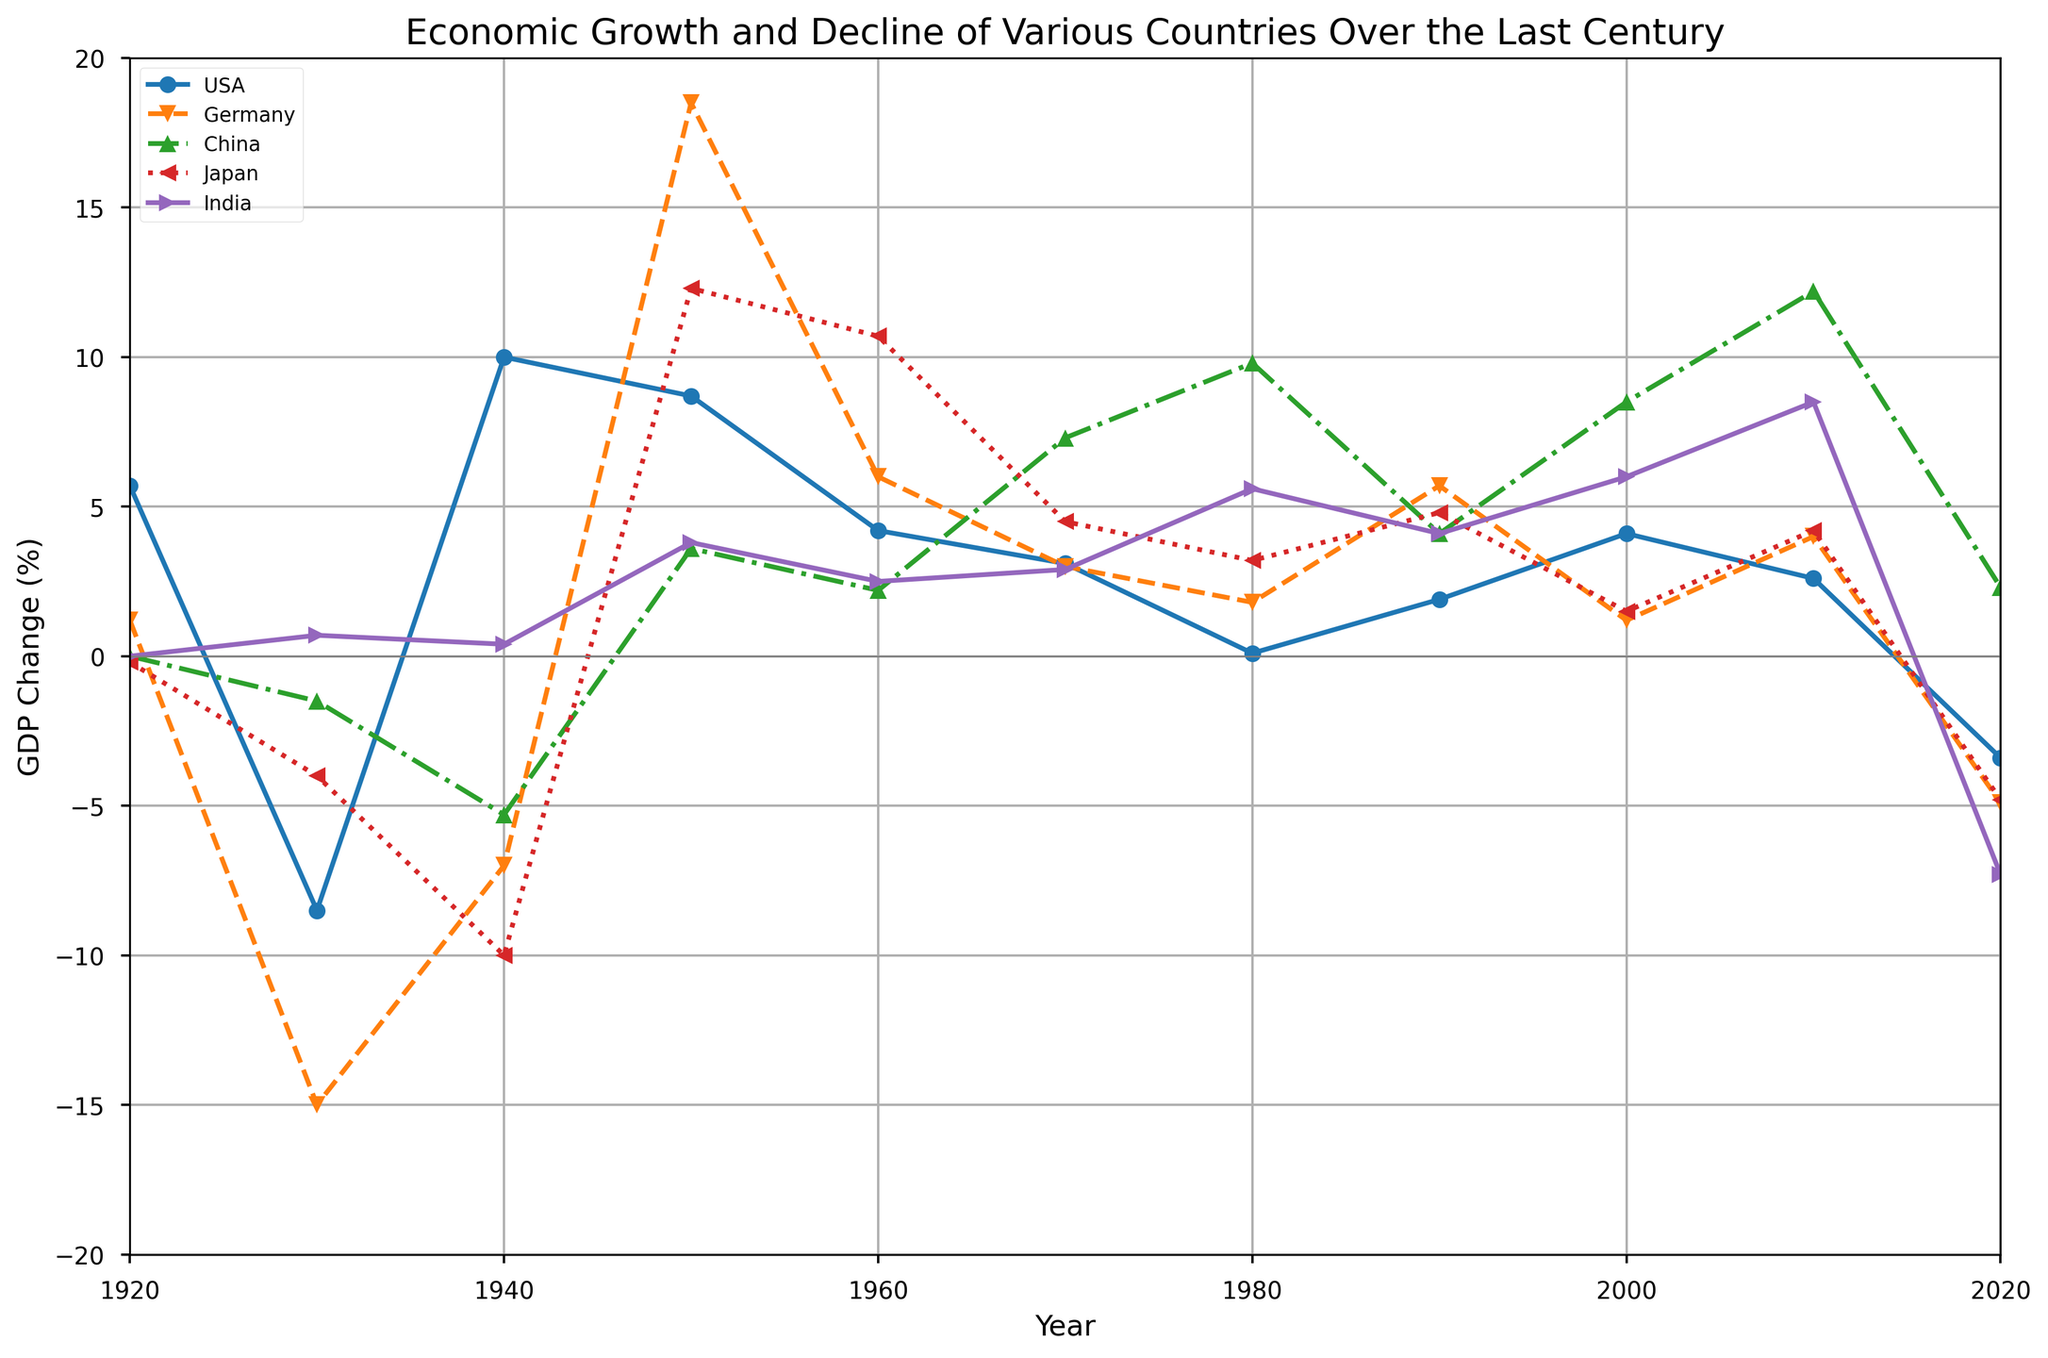How did the economic growth of the USA change from 1930 to 1940? The chart shows negative GDP change in the USA in 1930 and positive GDP change in 1940. Thus, there was an increase. Specifically, from -8.5% in 1930 to 10.0% in 1940.
Answer: Economic growth significantly increased Which country had the highest GDP change in 1950? By observing the peaks on the chart for 1950, Germany had the highest GDP change. The GDP change for Germany in 1950 is 18.5%, which is the highest among all countries that year.
Answer: Germany How does the GDP change in 2020 for India compare with Japan? The GDP change for India in 2020 is -7.3% while for Japan it is -4.8%. Comparing these values, India's GDP decline is greater than Japan's.
Answer: India's GDP decline is greater Which two countries experienced a negative GDP growth during the 1930s? Observing the drop below zero on the chart for the 1930s, the USA and Germany had negative GDP growth. USA has -8.5% and Germany has -15.0% in the 1930s.
Answer: USA and Germany What's the average GDP change of China in the last four observed periods (1990, 2000, 2010, 2020)? The GDP changes for China in those periods are 4.1, 8.5, 12.2, and 2.3. Summing them gives 27.1. Dividing by 4 gives the average value of approximately 6.775%.
Answer: 6.775% Which country had higher economic growth during the 1960s, Japan or India? Observing the points for each country in the 1960s on the chart, Japan had a GDP change of 10.7% whereas India had 2.5%. Thus, Japan had higher growth.
Answer: Japan Did any country show consistent year-over-year GDP increases from 1920 to 2020? Observing the chart, no country shows a consistent year-over-year increase throughout the whole period. Each country has periods of both positive and negative GDP changes.
Answer: No In which decade did Germany experience the largest growth rate increase? By identifying the largest upward spike on Germany's line, the 1950s show the largest increase from previous years, with a spike to 18.5%.
Answer: 1950s 